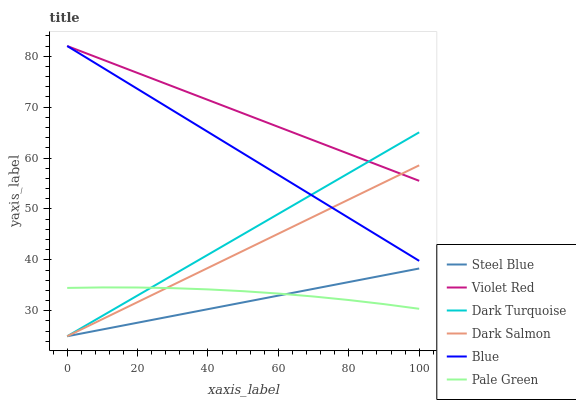Does Steel Blue have the minimum area under the curve?
Answer yes or no. Yes. Does Violet Red have the maximum area under the curve?
Answer yes or no. Yes. Does Dark Turquoise have the minimum area under the curve?
Answer yes or no. No. Does Dark Turquoise have the maximum area under the curve?
Answer yes or no. No. Is Steel Blue the smoothest?
Answer yes or no. Yes. Is Pale Green the roughest?
Answer yes or no. Yes. Is Violet Red the smoothest?
Answer yes or no. No. Is Violet Red the roughest?
Answer yes or no. No. Does Dark Turquoise have the lowest value?
Answer yes or no. Yes. Does Violet Red have the lowest value?
Answer yes or no. No. Does Violet Red have the highest value?
Answer yes or no. Yes. Does Dark Turquoise have the highest value?
Answer yes or no. No. Is Pale Green less than Blue?
Answer yes or no. Yes. Is Blue greater than Pale Green?
Answer yes or no. Yes. Does Dark Turquoise intersect Blue?
Answer yes or no. Yes. Is Dark Turquoise less than Blue?
Answer yes or no. No. Is Dark Turquoise greater than Blue?
Answer yes or no. No. Does Pale Green intersect Blue?
Answer yes or no. No. 